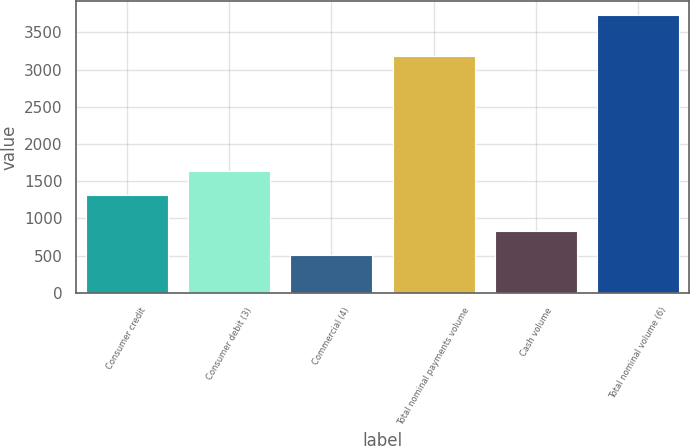Convert chart. <chart><loc_0><loc_0><loc_500><loc_500><bar_chart><fcel>Consumer credit<fcel>Consumer debit (3)<fcel>Commercial (4)<fcel>Total nominal payments volume<fcel>Cash volume<fcel>Total nominal volume (6)<nl><fcel>1309<fcel>1631.6<fcel>506<fcel>3188<fcel>828.6<fcel>3732<nl></chart> 